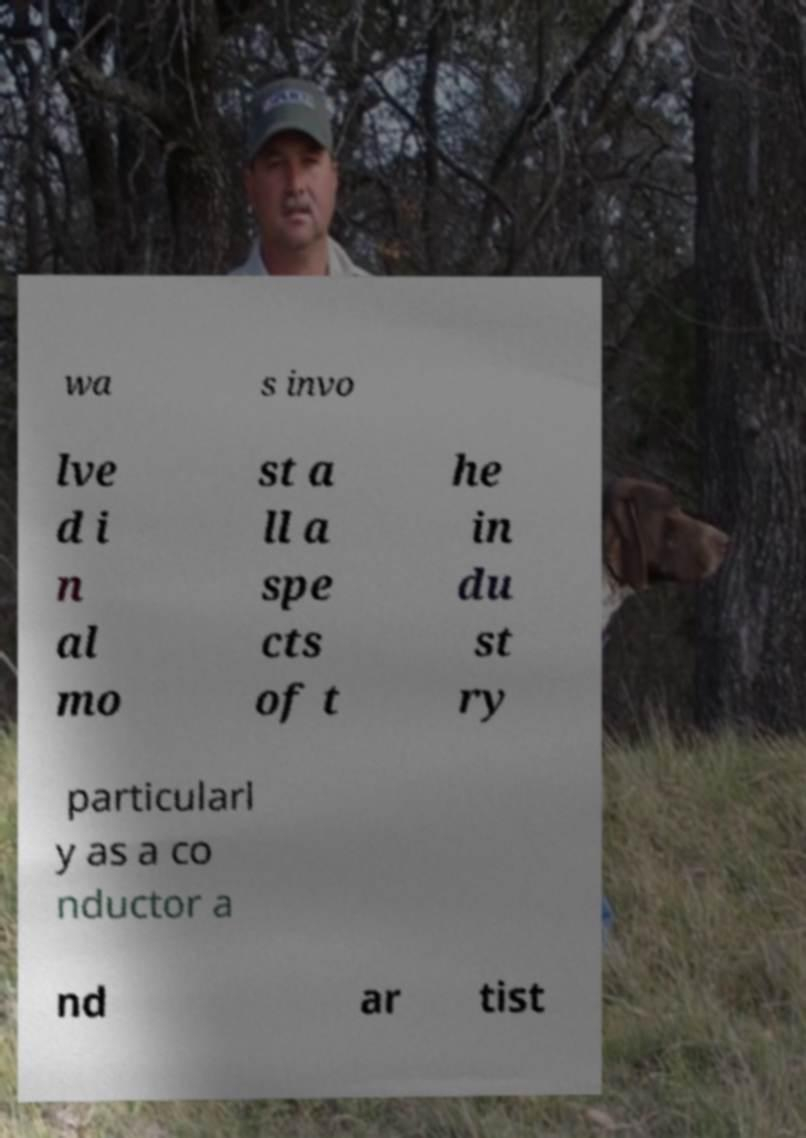What messages or text are displayed in this image? I need them in a readable, typed format. wa s invo lve d i n al mo st a ll a spe cts of t he in du st ry particularl y as a co nductor a nd ar tist 